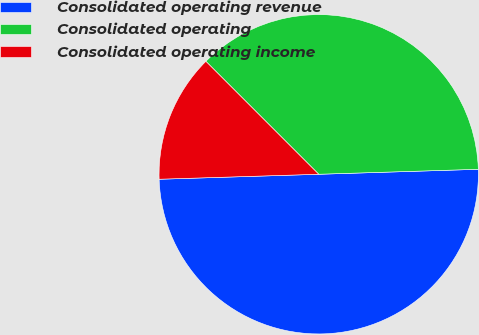<chart> <loc_0><loc_0><loc_500><loc_500><pie_chart><fcel>Consolidated operating revenue<fcel>Consolidated operating<fcel>Consolidated operating income<nl><fcel>50.0%<fcel>37.0%<fcel>13.0%<nl></chart> 